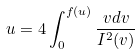Convert formula to latex. <formula><loc_0><loc_0><loc_500><loc_500>u = 4 \int _ { 0 } ^ { f ( u ) } \frac { v d v } { I ^ { 2 } ( v ) }</formula> 